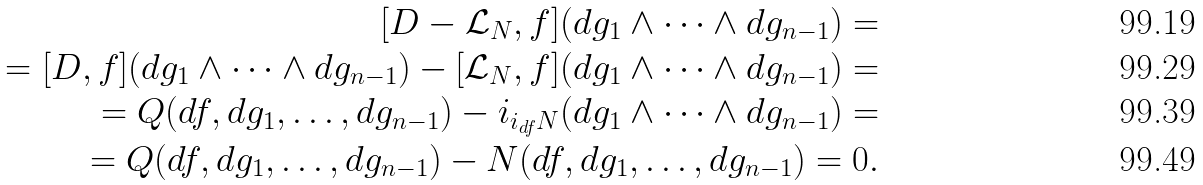Convert formula to latex. <formula><loc_0><loc_0><loc_500><loc_500>[ D - \mathcal { L } _ { N } , f ] ( d g _ { 1 } \wedge \dots \wedge d g _ { n - 1 } ) = \\ = [ D , f ] ( d g _ { 1 } \wedge \dots \wedge d g _ { n - 1 } ) - [ \mathcal { L } _ { N } , f ] ( d g _ { 1 } \wedge \dots \wedge d g _ { n - 1 } ) = \\ = Q ( d f , d g _ { 1 } , \dots , d g _ { n - 1 } ) - i _ { i _ { d f } N } ( d g _ { 1 } \wedge \dots \wedge d g _ { n - 1 } ) = \\ = Q ( d f , d g _ { 1 } , \dots , d g _ { n - 1 } ) - N ( d f , d g _ { 1 } , \dots , d g _ { n - 1 } ) = 0 .</formula> 